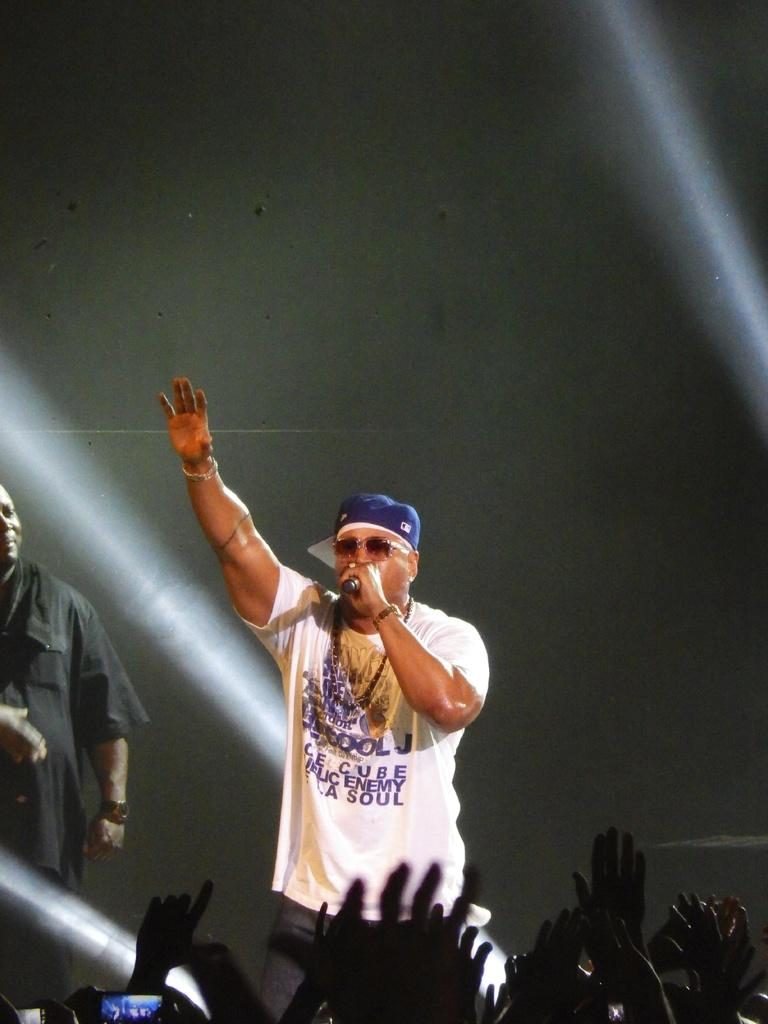<image>
Provide a brief description of the given image. A rapper wears a shirt with public enemy and a blue baseball hat. 